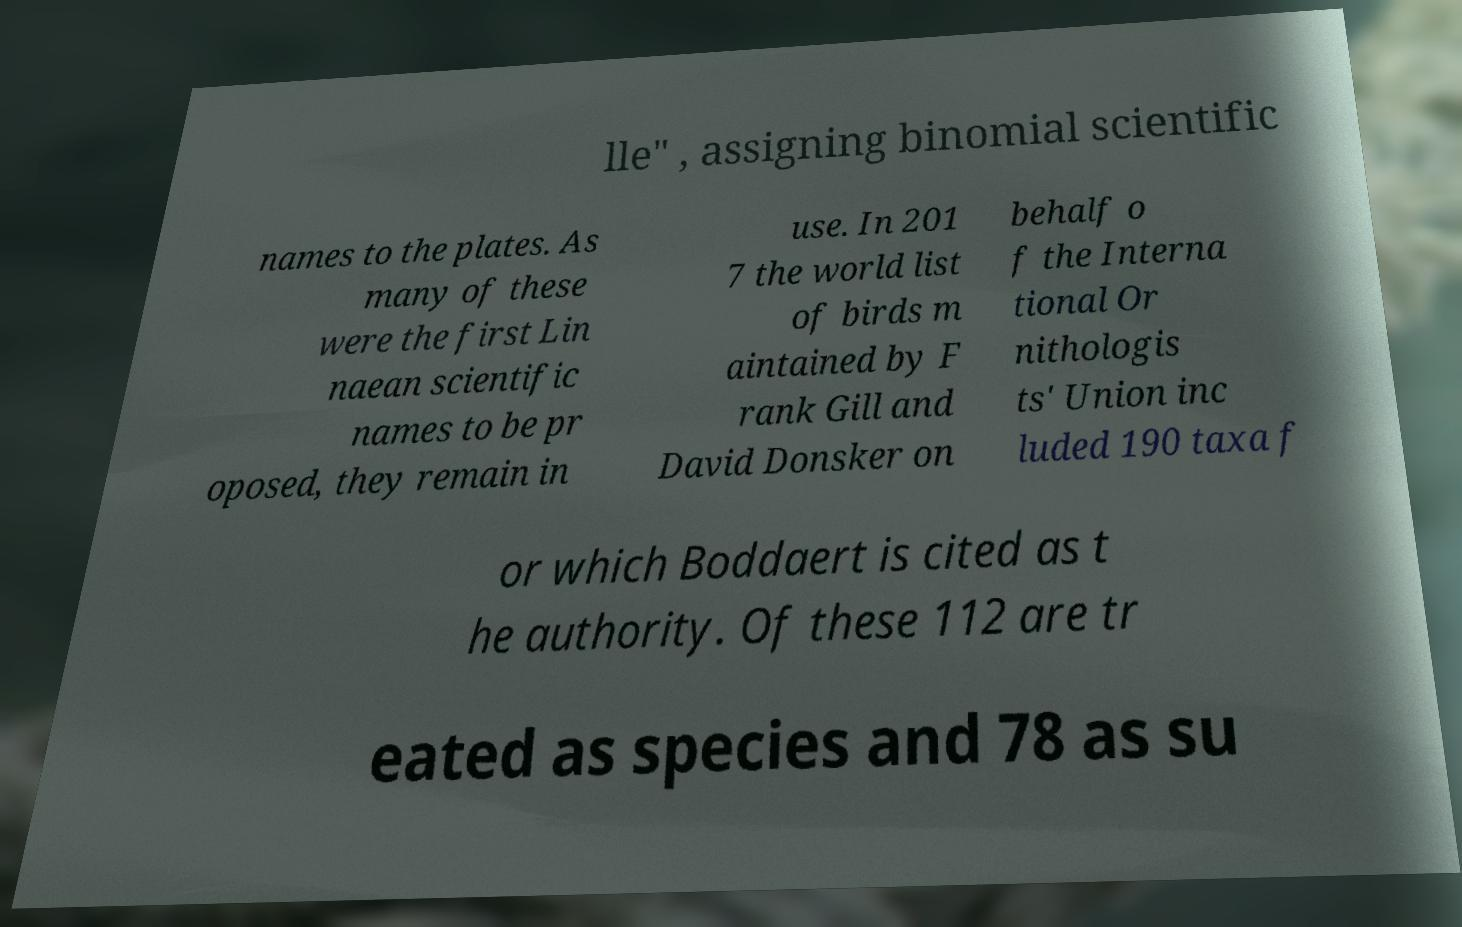Could you assist in decoding the text presented in this image and type it out clearly? lle" , assigning binomial scientific names to the plates. As many of these were the first Lin naean scientific names to be pr oposed, they remain in use. In 201 7 the world list of birds m aintained by F rank Gill and David Donsker on behalf o f the Interna tional Or nithologis ts' Union inc luded 190 taxa f or which Boddaert is cited as t he authority. Of these 112 are tr eated as species and 78 as su 